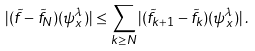Convert formula to latex. <formula><loc_0><loc_0><loc_500><loc_500>| ( \tilde { f } - \tilde { f } _ { N } ) ( \psi _ { x } ^ { \lambda } ) | \leq \sum _ { k \geq N } | ( \tilde { f } _ { k + 1 } - \tilde { f } _ { k } ) ( \psi _ { x } ^ { \lambda } ) | \, .</formula> 